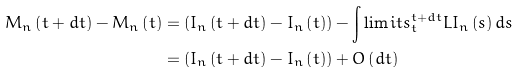<formula> <loc_0><loc_0><loc_500><loc_500>M _ { n } \left ( t + d t \right ) - M _ { n } \left ( t \right ) & = \left ( I _ { n } \left ( t + d t \right ) - I _ { n } \left ( t \right ) \right ) - \int \lim i t s _ { t } ^ { t + d t } L I _ { n } \left ( s \right ) d s \\ & = \left ( I _ { n } \left ( t + d t \right ) - I _ { n } \left ( t \right ) \right ) + O \left ( d t \right )</formula> 